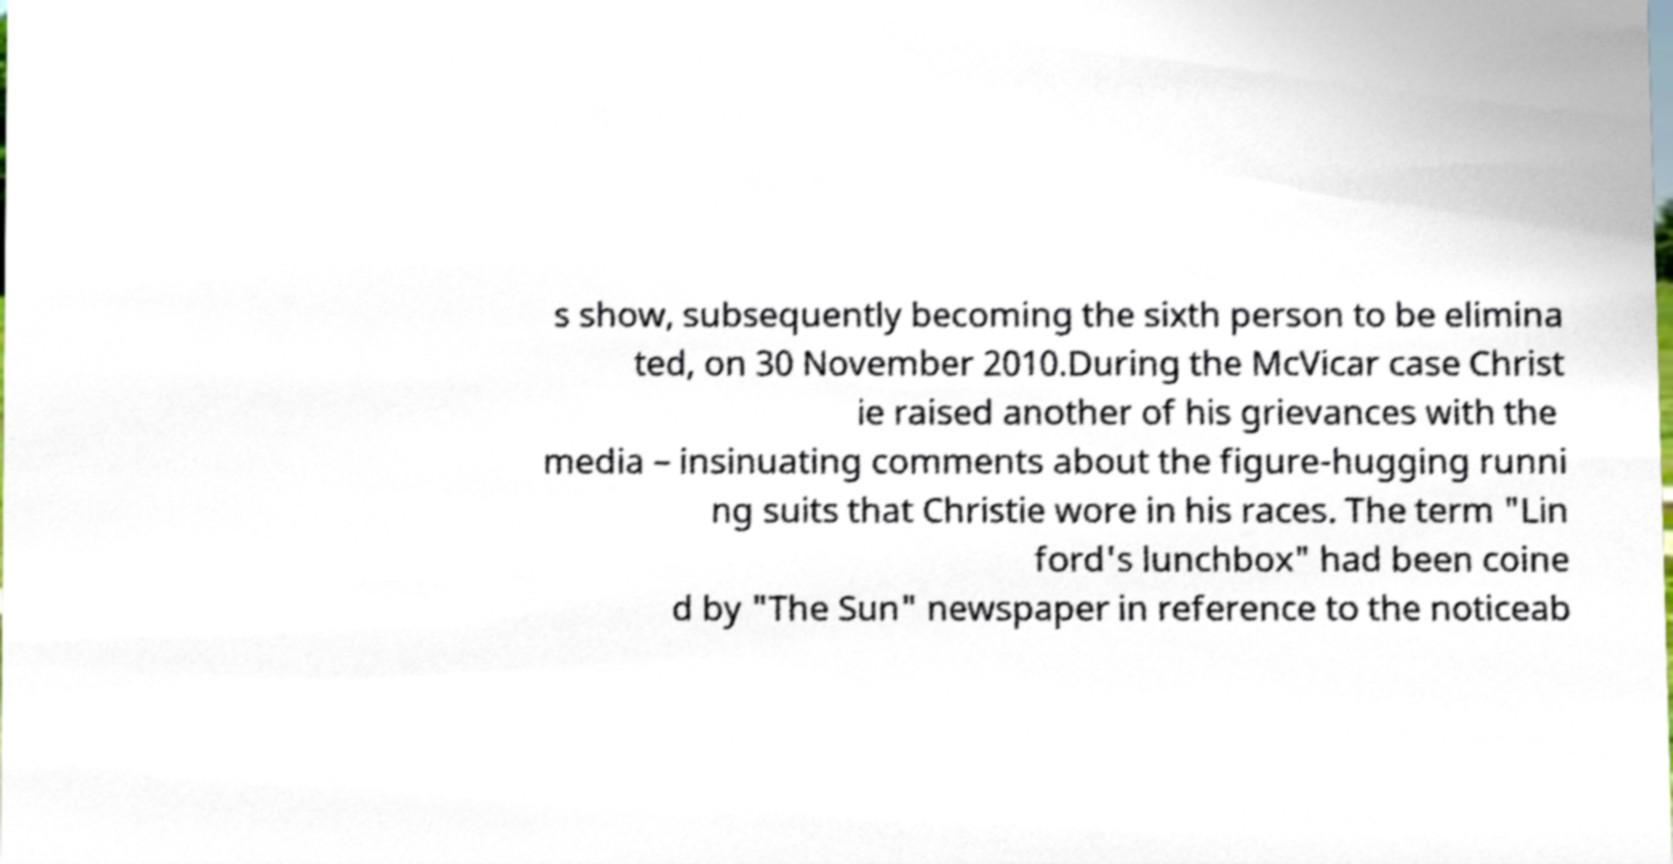What messages or text are displayed in this image? I need them in a readable, typed format. s show, subsequently becoming the sixth person to be elimina ted, on 30 November 2010.During the McVicar case Christ ie raised another of his grievances with the media – insinuating comments about the figure-hugging runni ng suits that Christie wore in his races. The term "Lin ford's lunchbox" had been coine d by "The Sun" newspaper in reference to the noticeab 